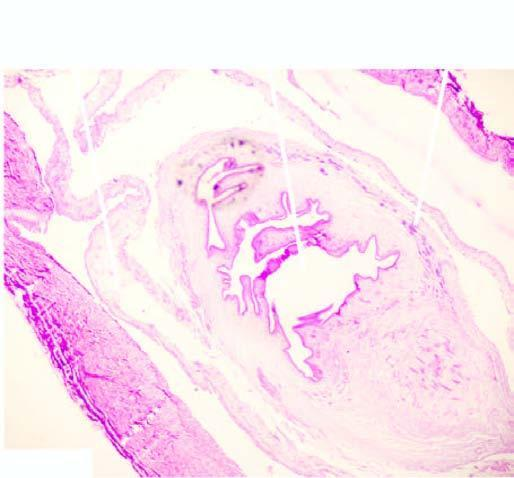s the worm seen in the cyst while the cyst wall shows palisade layer of histiocytes?
Answer the question using a single word or phrase. Yes 